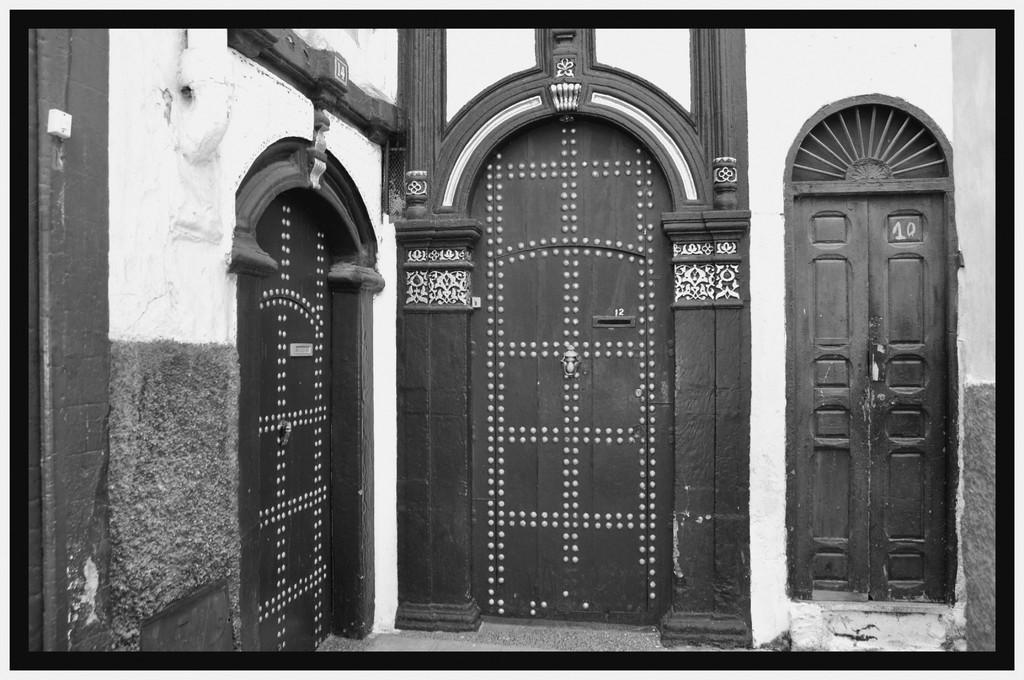What type of architectural feature can be seen in the image? There are doors and a wall in the image. What other objects can be seen in the image? There is a pipe and a switchboard in the image. How many lizards are sitting on the switchboard in the image? There are no lizards present in the image; the switchboard is the only object visible in that area. 